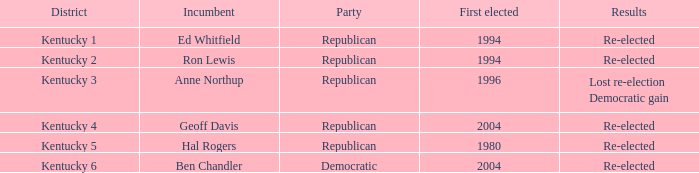In what year was the republican incumbent from Kentucky 2 district first elected? 1994.0. 